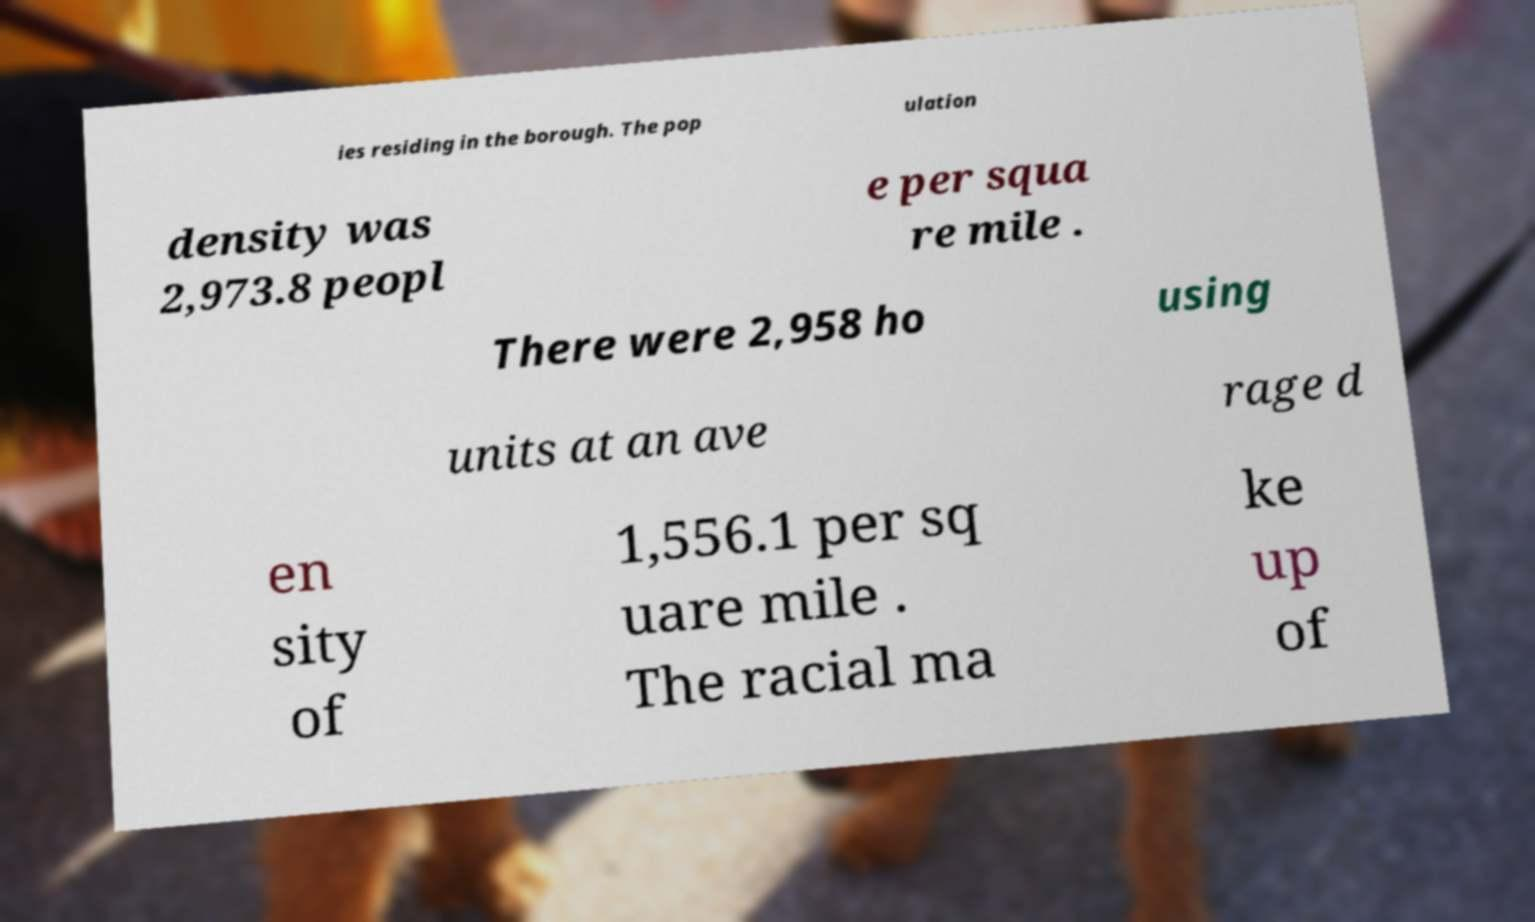Please identify and transcribe the text found in this image. ies residing in the borough. The pop ulation density was 2,973.8 peopl e per squa re mile . There were 2,958 ho using units at an ave rage d en sity of 1,556.1 per sq uare mile . The racial ma ke up of 